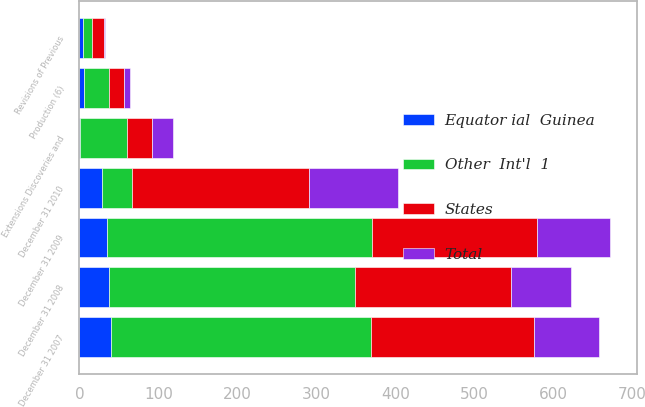Convert chart. <chart><loc_0><loc_0><loc_500><loc_500><stacked_bar_chart><ecel><fcel>December 31 2007<fcel>Production (6)<fcel>December 31 2008<fcel>Extensions Discoveries and<fcel>December 31 2009<fcel>Revisions of Previous<fcel>December 31 2010<nl><fcel>States<fcel>207<fcel>18<fcel>198<fcel>32<fcel>209<fcel>15<fcel>225<nl><fcel>Total<fcel>82<fcel>8<fcel>75<fcel>26<fcel>92<fcel>1<fcel>112<nl><fcel>Equator ial  Guinea<fcel>40<fcel>6<fcel>38<fcel>1<fcel>35<fcel>5<fcel>28<nl><fcel>Other  Int'l  1<fcel>329<fcel>32<fcel>311<fcel>59<fcel>336<fcel>11<fcel>38<nl></chart> 